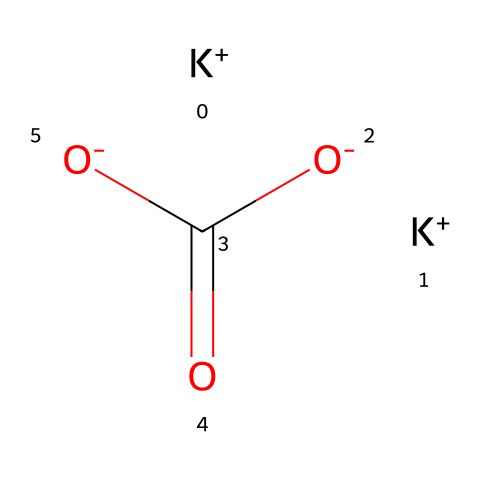What is the main ionic component of this chemical? The chemical structure reveals that it contains potassium ions represented by [K+]. This indicates that the main ionic component is potassium.
Answer: potassium How many carboxylate groups are present in this molecule? The structure shows two carboxylate groups (indicated by [O-]C(=O)). Each group consists of a carbon atom double bonded to an oxygen and single bonded to another oxygen, which confirms the presence of two such groups.
Answer: two What type of chemical compound is this? Analyzing the structure, the presence of potassium and carboxylate groups suggests that this substance is a salt, specifically a potassium salt derived from a weak acid and a strong base.
Answer: salt Which elements are present in this chemical? By examining the chemical structure, the elements can be identified as potassium (K), carbon (C), and oxygen (O). Counting the different atomic symbols in the SMILES representation confirms their presence.
Answer: potassium, carbon, oxygen How many potassium ions are present in this molecule? The structure shows two potassium ions indicated by [K+]. A count of these symbols confirms the presence of two potassium ions in the formula.
Answer: two 